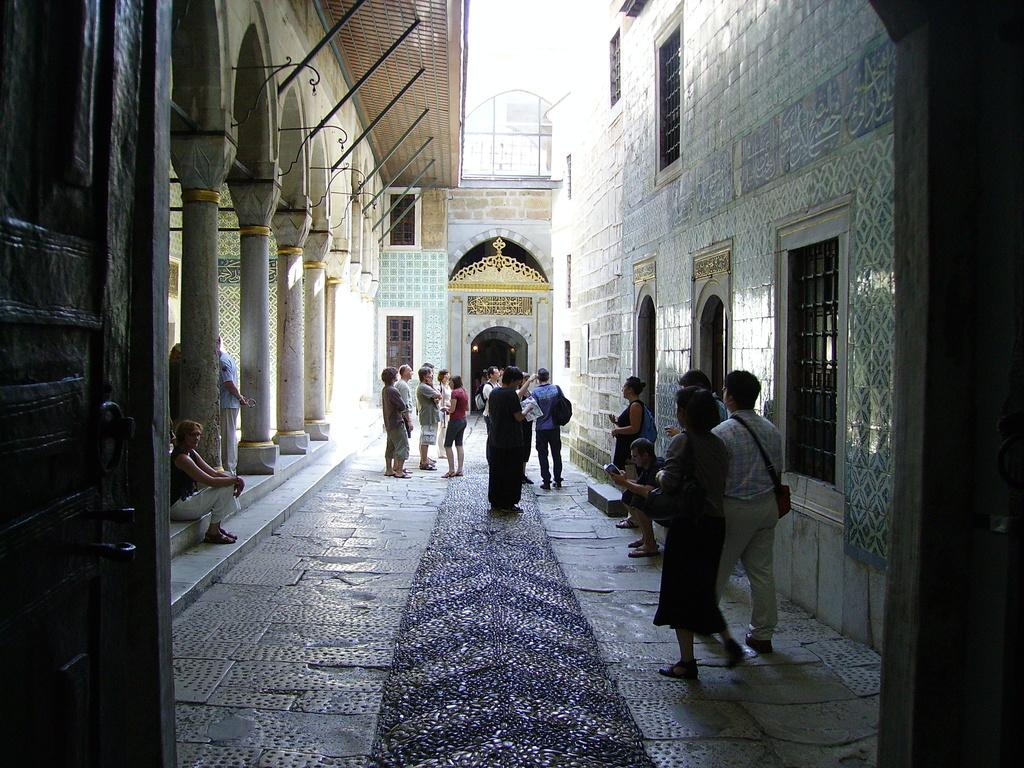How many people are in the image? There are many people standing in the image. Are there any people sitting in the image? Yes, two people are sitting in the image. What are the people wearing? The people are wearing clothes. Where is the scene taking place? The scene takes place on a footpath. What architectural features can be seen in the image? There are pillars in the image. What structure is visible in the image? There is a building in the image. What part of the natural environment is visible in the image? The sky is visible in the image. Can you see any ghosts in the image? No, there are no ghosts present in the image. What type of room is visible in the image? There is no room visible in the image; the scene takes place on a footpath. 